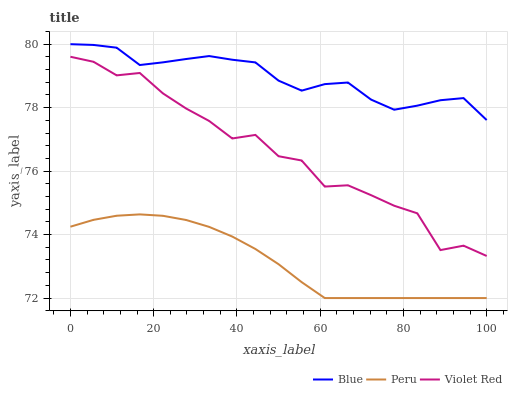Does Peru have the minimum area under the curve?
Answer yes or no. Yes. Does Blue have the maximum area under the curve?
Answer yes or no. Yes. Does Violet Red have the minimum area under the curve?
Answer yes or no. No. Does Violet Red have the maximum area under the curve?
Answer yes or no. No. Is Peru the smoothest?
Answer yes or no. Yes. Is Violet Red the roughest?
Answer yes or no. Yes. Is Violet Red the smoothest?
Answer yes or no. No. Is Peru the roughest?
Answer yes or no. No. Does Peru have the lowest value?
Answer yes or no. Yes. Does Violet Red have the lowest value?
Answer yes or no. No. Does Blue have the highest value?
Answer yes or no. Yes. Does Violet Red have the highest value?
Answer yes or no. No. Is Peru less than Violet Red?
Answer yes or no. Yes. Is Violet Red greater than Peru?
Answer yes or no. Yes. Does Peru intersect Violet Red?
Answer yes or no. No. 